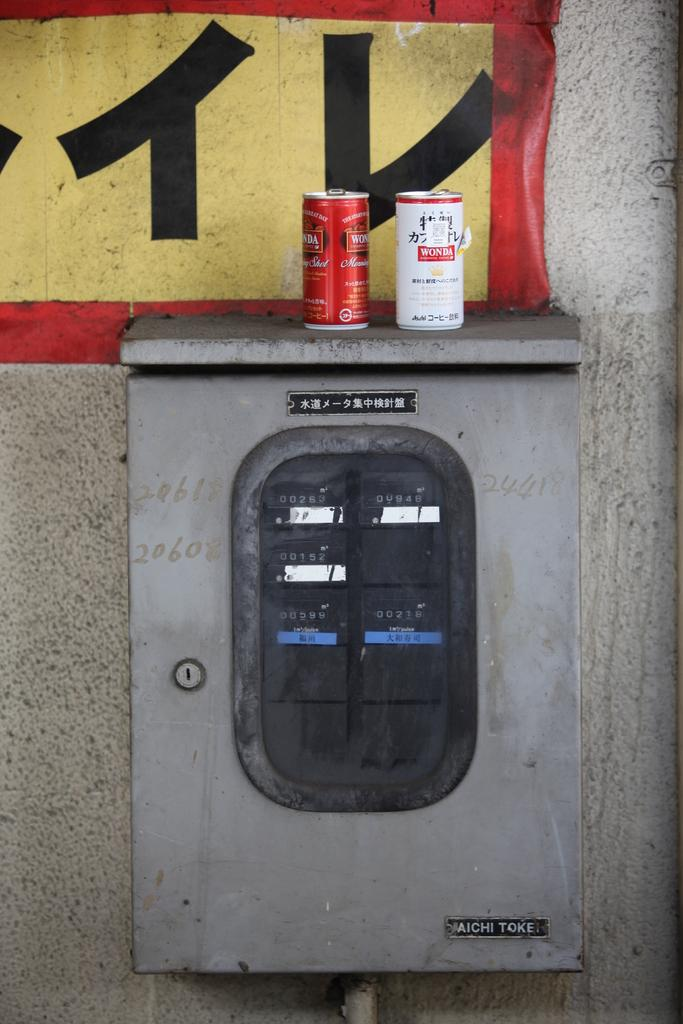<image>
Describe the image concisely. A couple of Wonda cans atop an Aichi Tokei electrical box. 